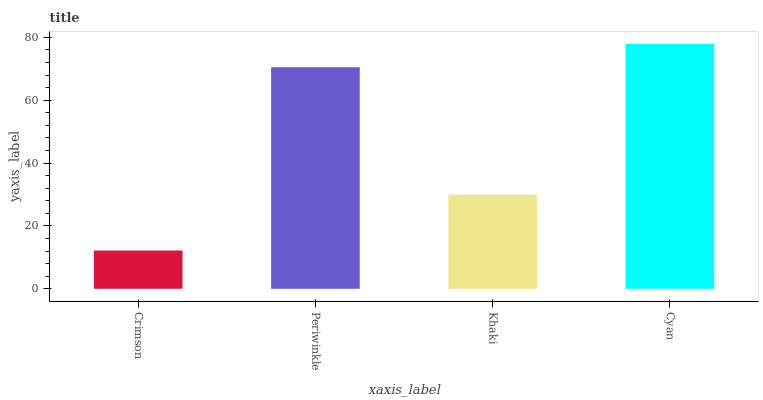Is Crimson the minimum?
Answer yes or no. Yes. Is Cyan the maximum?
Answer yes or no. Yes. Is Periwinkle the minimum?
Answer yes or no. No. Is Periwinkle the maximum?
Answer yes or no. No. Is Periwinkle greater than Crimson?
Answer yes or no. Yes. Is Crimson less than Periwinkle?
Answer yes or no. Yes. Is Crimson greater than Periwinkle?
Answer yes or no. No. Is Periwinkle less than Crimson?
Answer yes or no. No. Is Periwinkle the high median?
Answer yes or no. Yes. Is Khaki the low median?
Answer yes or no. Yes. Is Crimson the high median?
Answer yes or no. No. Is Periwinkle the low median?
Answer yes or no. No. 